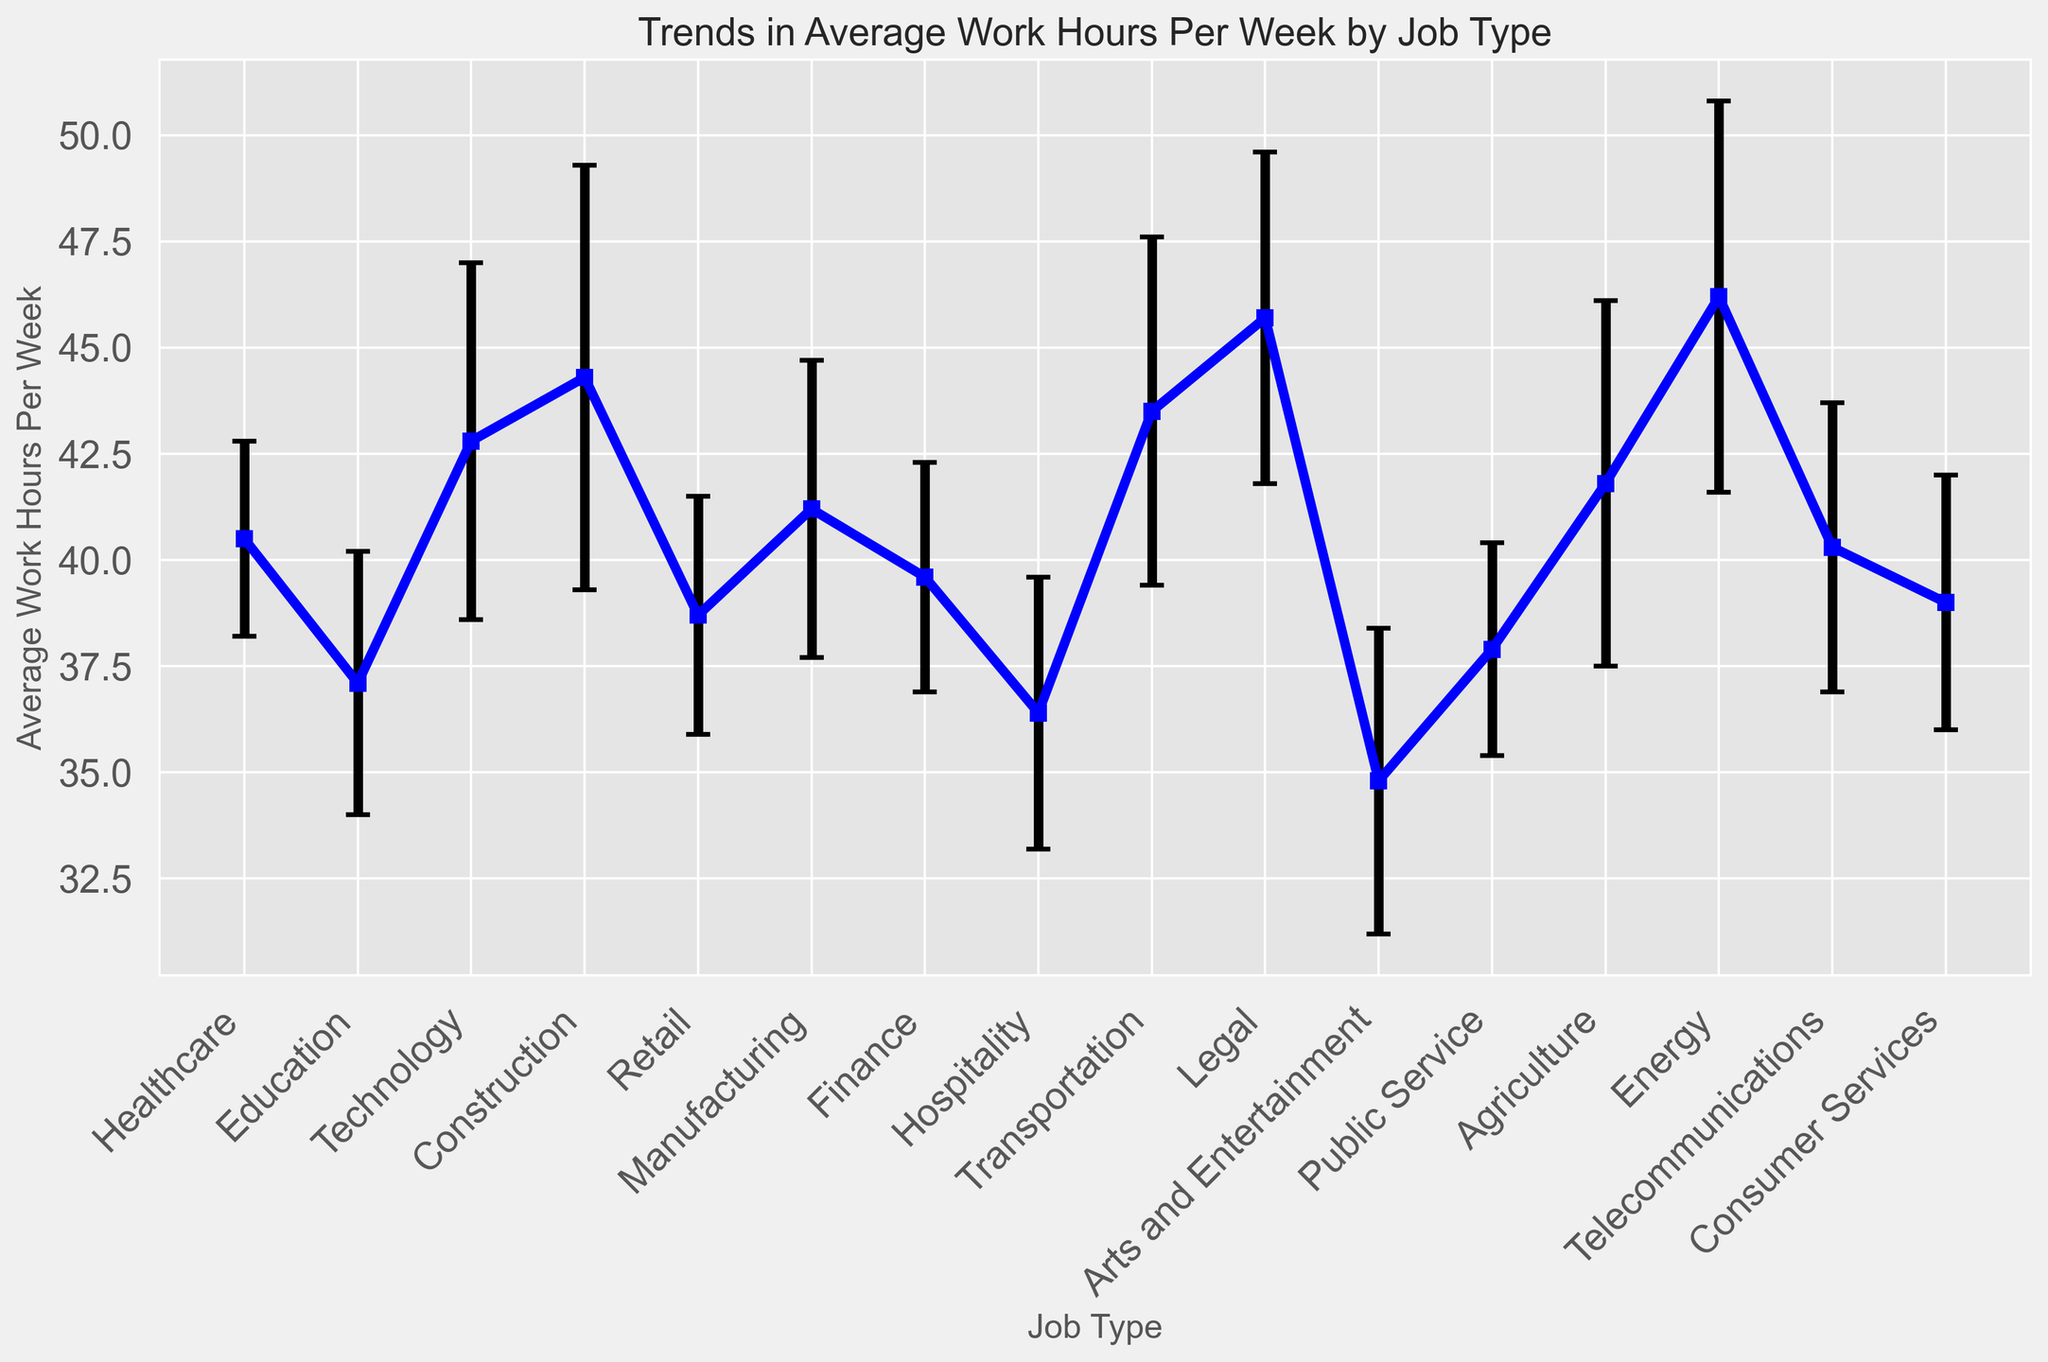Which job type has the highest average work hours per week? By looking at the figure, we can see that the job type with the highest average work hours per week has the highest point along the y-axis.
Answer: Energy What is the difference in average work hours per week between Legal and Education job types? Look at the average work hours for Legal and Education from the figure and subtract the average work hours of Education from Legal.
Answer: 8.6 hours Which job type has the lowest standard deviation in work hours? By checking the lengths of the error bars in the figure, the job type with the shortest error bar has the lowest standard deviation.
Answer: Public Service How do the average work hours for Technology compare to those for Healthcare? Compare the positions of the Technology and Healthcare job types along the y-axis to see which one is higher.
Answer: Technology is higher than Healthcare What is the average of the average work hours for the job types Healthcare, Finance, and Hospitality? Add the average work hours of Healthcare, Finance, and Hospitality from the figure, then divide by 3.
Answer: 38.83 hours Which job type has a higher average work hours per week, Manufacturing or Telecommunications? Compare the points for Manufacturing and Telecommunications along the y-axis to see which one is higher.
Answer: Manufacturing Considering standard deviations, which job type shows the widest range of work hours? The job type with the longest error bar reflects the widest range of work hours due to its higher standard deviation.
Answer: Construction What is the combined average work hours per week for Transportation and Agriculture? Add the average work hours for Transportation and Agriculture from the figure.
Answer: 85.3 hours Which job type has the closest average work hours to the average work hours of Public Service? Find the job type with an average work hours value close to that of Public Service along the y-axis.
Answer: Finance 